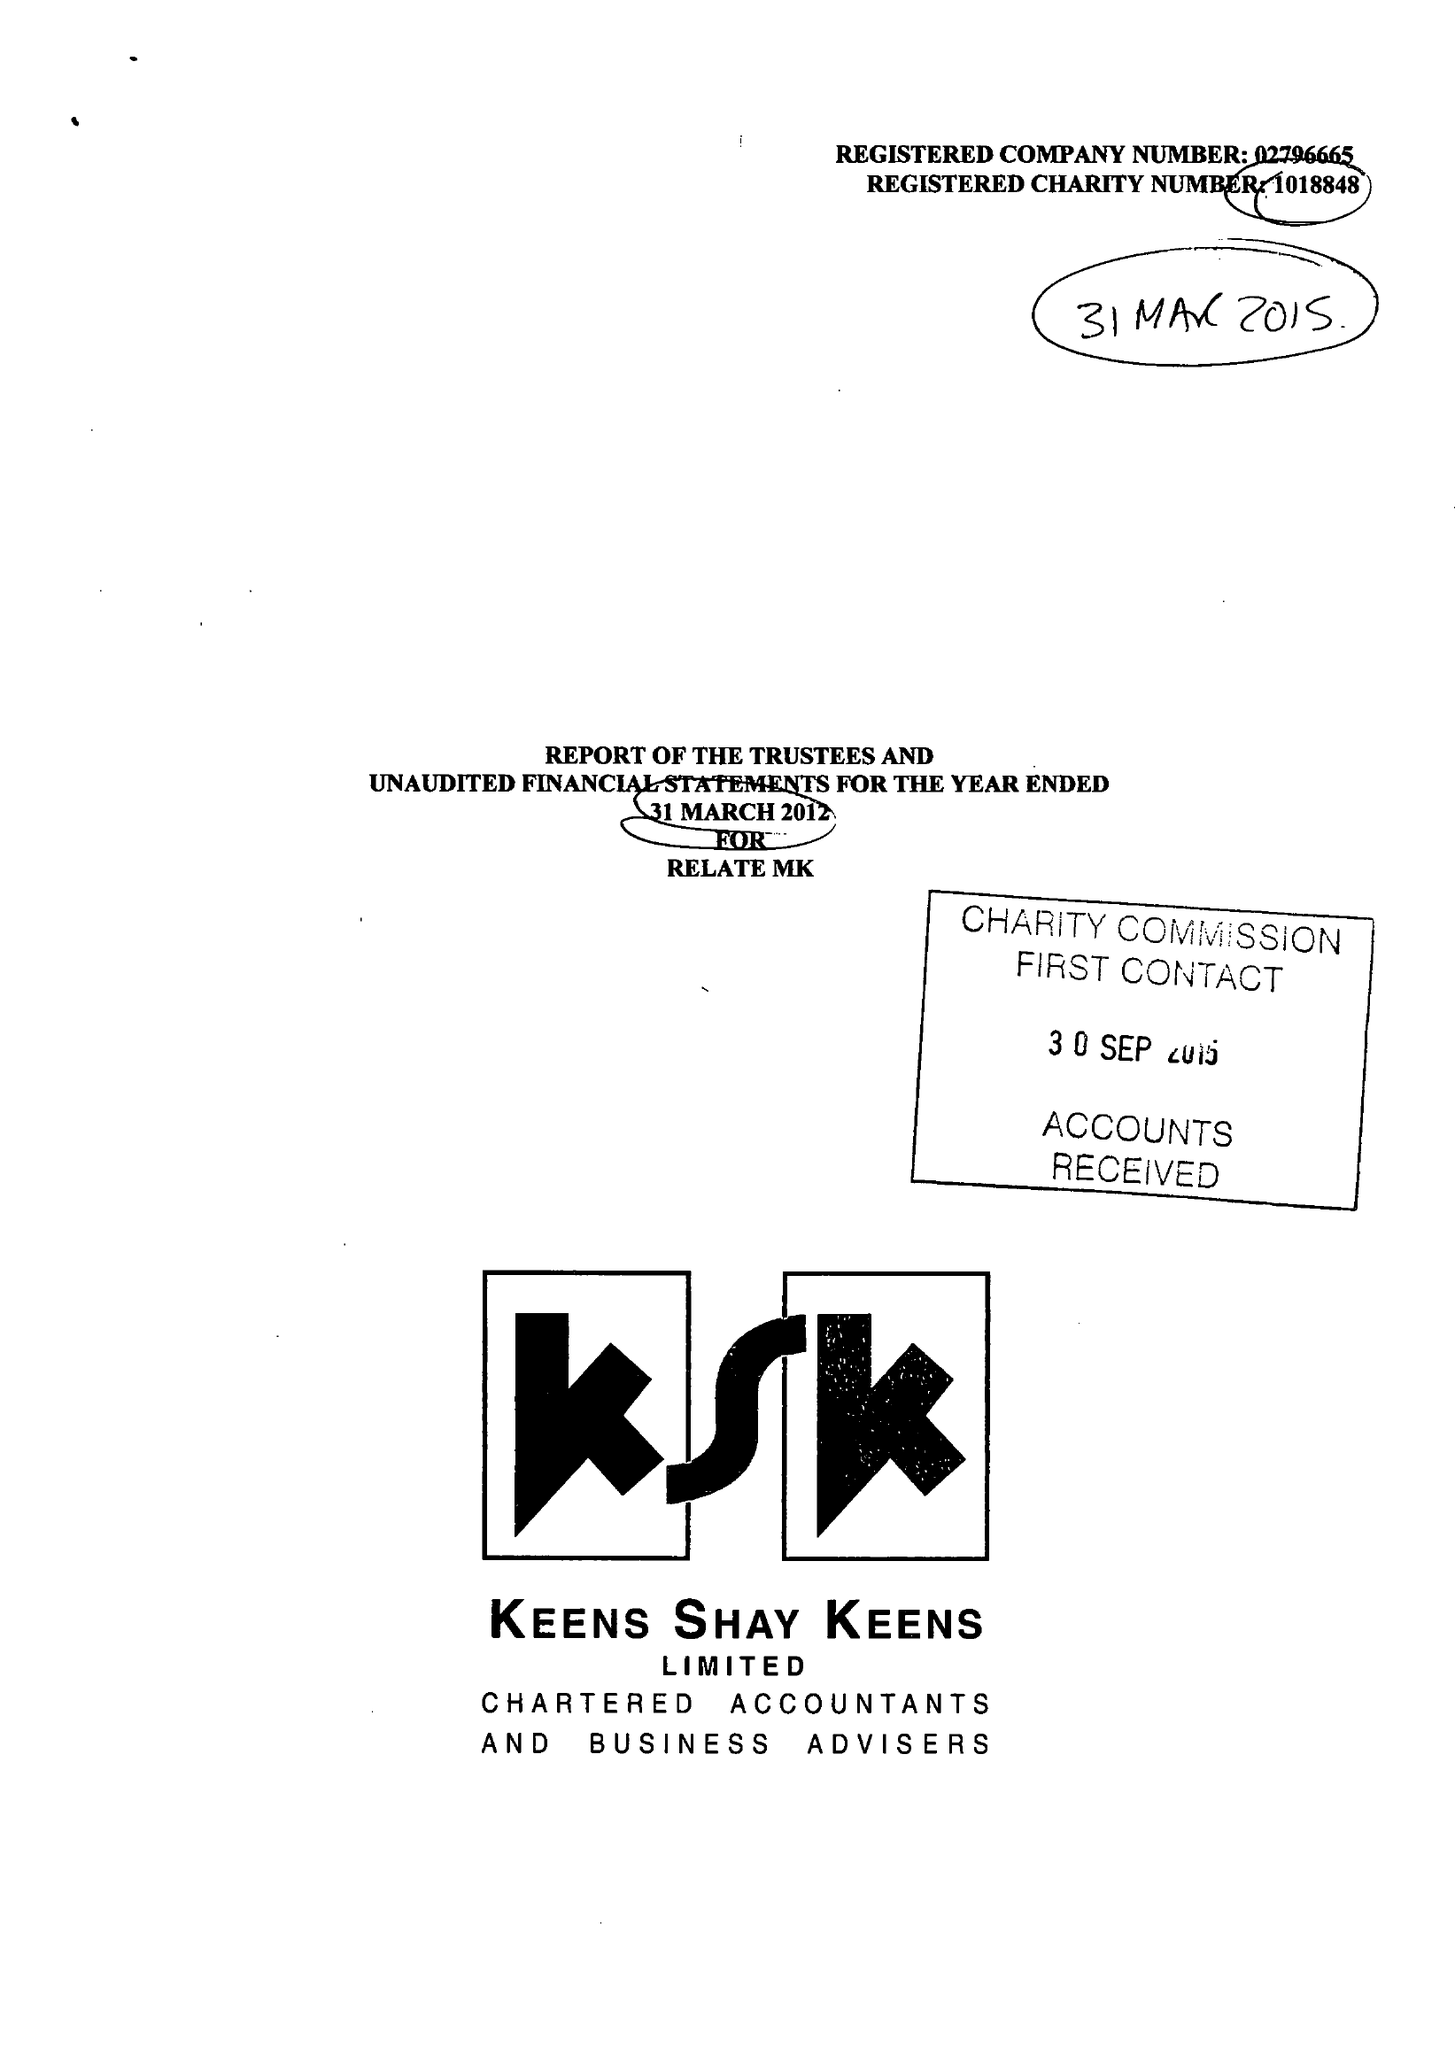What is the value for the address__post_town?
Answer the question using a single word or phrase. MILTON KEYNES 